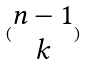Convert formula to latex. <formula><loc_0><loc_0><loc_500><loc_500>( \begin{matrix} n - 1 \\ k \end{matrix} )</formula> 